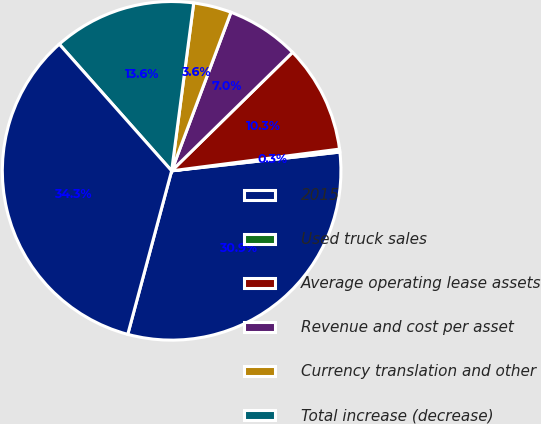Convert chart. <chart><loc_0><loc_0><loc_500><loc_500><pie_chart><fcel>2015<fcel>Used truck sales<fcel>Average operating lease assets<fcel>Revenue and cost per asset<fcel>Currency translation and other<fcel>Total increase (decrease)<fcel>2016<nl><fcel>30.94%<fcel>0.28%<fcel>10.29%<fcel>6.96%<fcel>3.62%<fcel>13.63%<fcel>34.28%<nl></chart> 